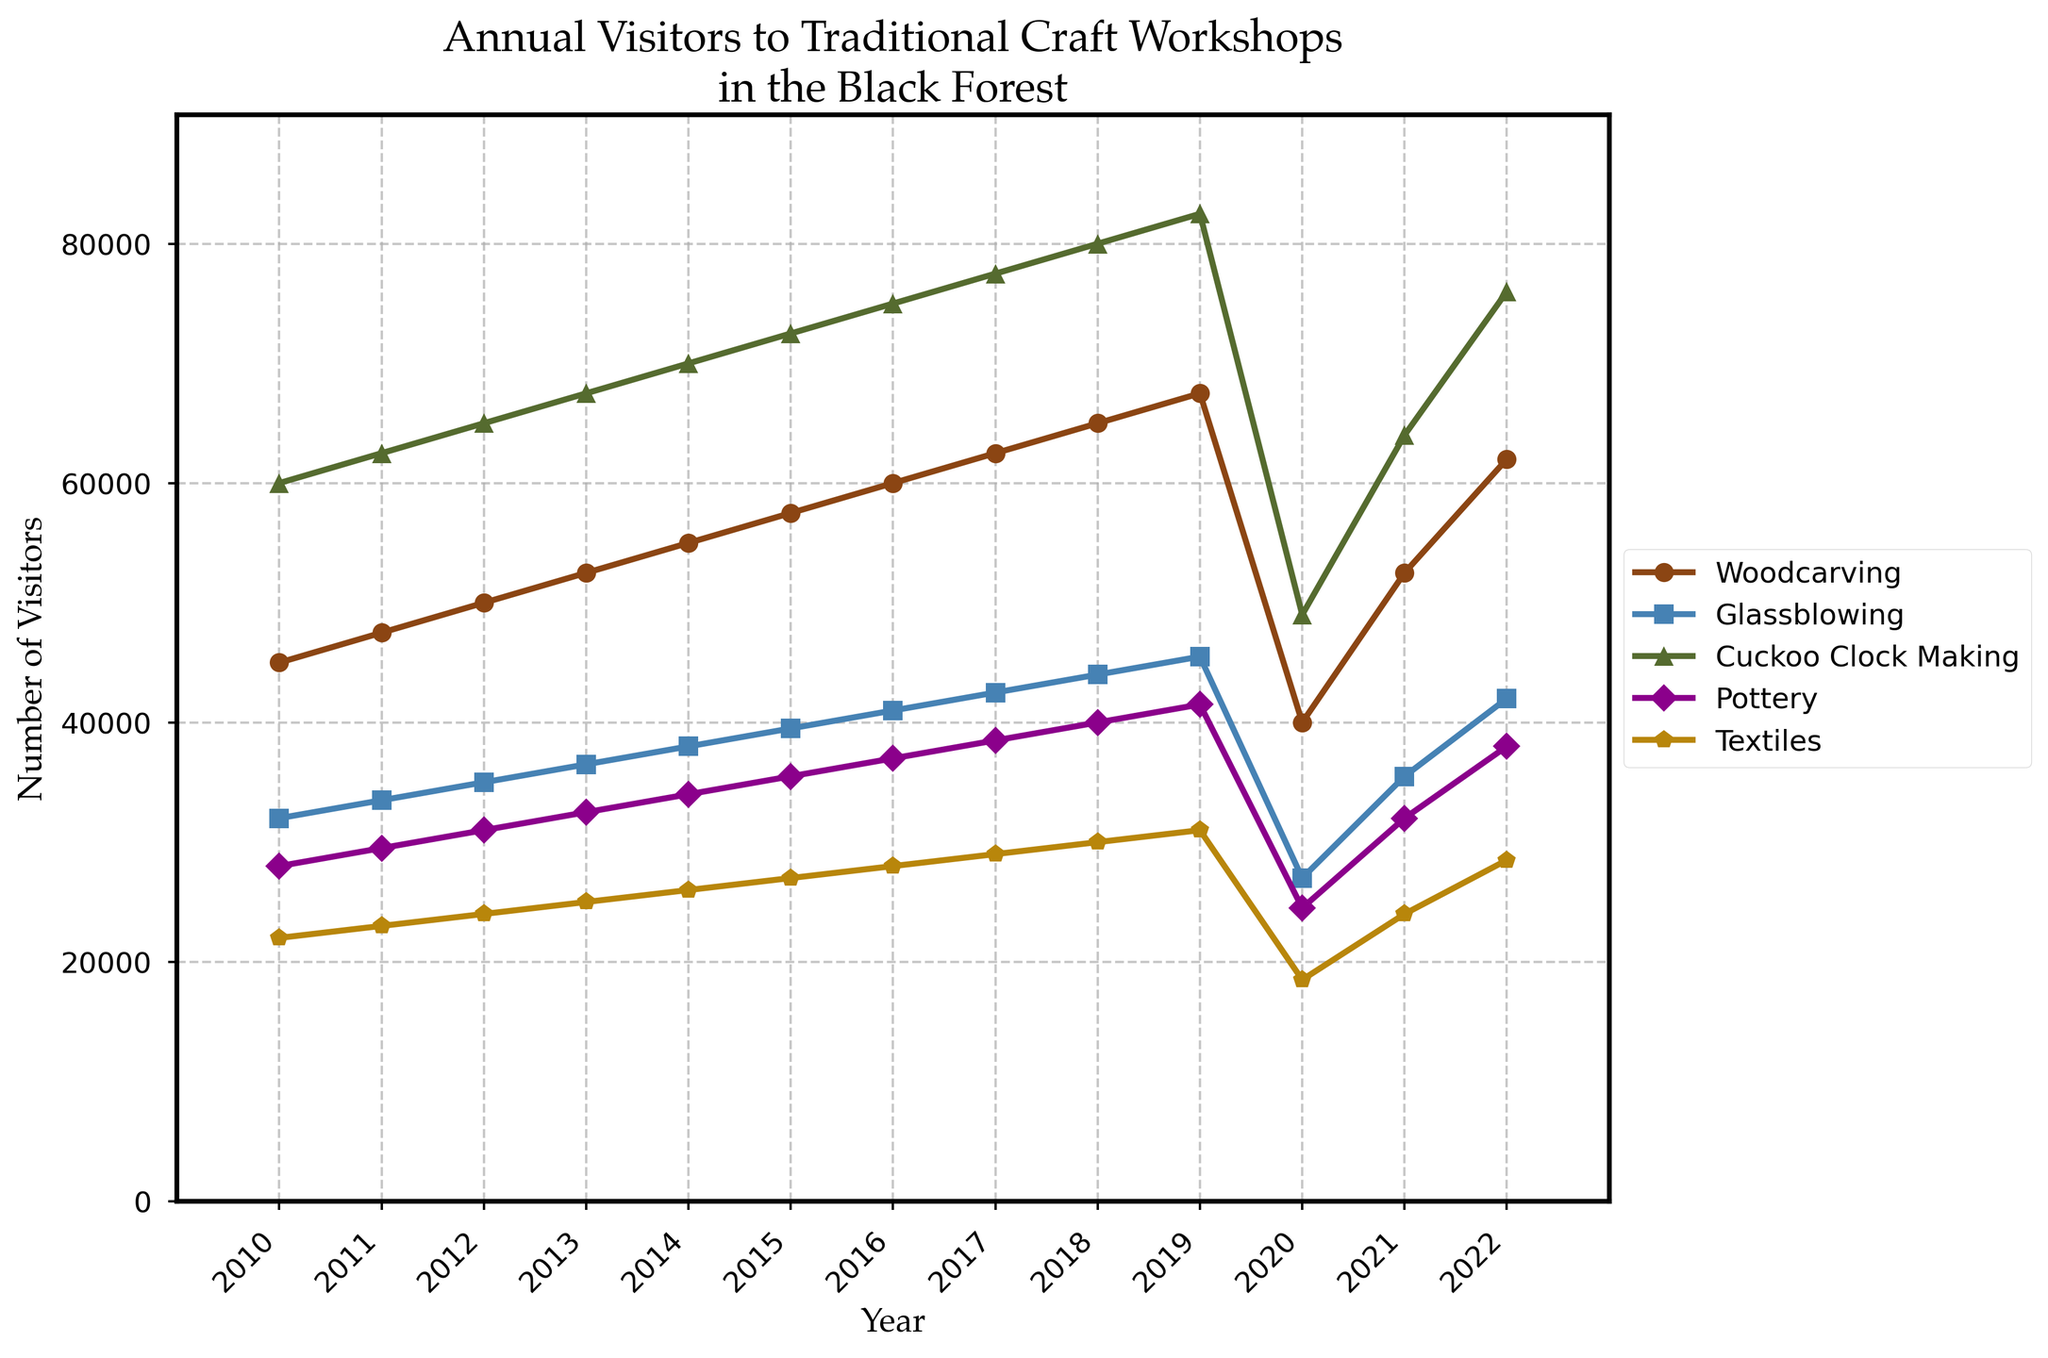When did Woodcarving reach 60,000 visitors for the first time? Identify the year in the Woodcarving line when the visitors number first reaches 60,000. In the chart, this occurs in 2016.
Answer: 2016 Which craft saw the highest number of visitors in 2019? Observe the data points for each craft type in 2019 and compare the visitor numbers. Cuckoo Clock Making reached 82,500, which is the highest among all crafts in that year.
Answer: Cuckoo Clock Making Did any craft experience a decrease in visitor numbers in 2020? Look at the chart to see the trendline between 2019 and 2020 for each craft type. All crafts experienced a significant decline in 2020.
Answer: Yes What is the difference in visitor numbers for Pottery between 2019 and 2020? Find the data points for Pottery in 2019 and 2020. Subtract the number in 2020 (24,500) from the number in 2019 (41,500).
Answer: 17,000 Which craft showed the most significant recovery in visitor numbers from 2020 to 2022? Calculate the difference in visitor numbers for each craft from 2020 to 2022, then find the maximum. Woodcarving showed the biggest recovery, increasing from 40,000 to 62,000, a difference of 22,000.
Answer: Woodcarving In which year did Textiles receive exactly 30,000 visitors? Identify the year in the Textiles line graph where the visitor count is exactly 30,000. It is in the year 2018.
Answer: 2018 Which craft had fewer visitors in 2022 than in 2019? Compare the visitor numbers of each craft between 2019 and 2022 and see if any decreased. Only Textiles had fewer visitors in 2022 (28,500) than in 2019 (31,000).
Answer: Textiles How did Glassblowing's visitor numbers change on average each year from 2010 to 2019? Calculate the annual increase by finding the difference between each year and taking the average from 2010 to 2019. (45,500 - 32,000) / 9 years = 1,500 visitors per year.
Answer: 1,500 What is the average number of visitors to Cuckoo Clock Making from 2010 to 2022? Sum all visitors from 2010 to 2022 for Cuckoo Clock Making and divide by the number of years (13). (60,000 + 62,500 + 65,000 + 67,500 + 70,000 + 72,500 + 75,000 + 77,500 + 80,000 + 82,500 + 49,000 + 64,000 + 76,000) / 13 = approximately 68,346.
Answer: 68,346 